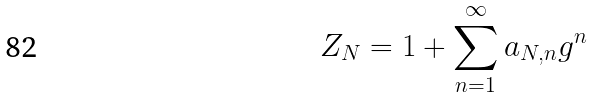<formula> <loc_0><loc_0><loc_500><loc_500>Z _ { N } = 1 + \sum _ { n = 1 } ^ { \infty } a _ { N , n } g ^ { n }</formula> 